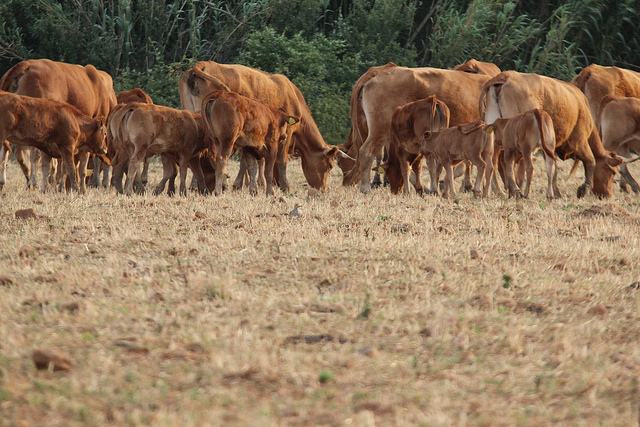How might this scene change with the seasons? In the heart of spring, this scene would burst with vitality as carpets of fresh green grass blanket the field, dotted with colorful wildflowers. The cows would seem livelier, their coats sleek under the invigorating sun. Summer would see the field bathed in warm, golden light with robust, verdant growth. By autumn, the grass would take on a richer, burnt hue, and the cows would graze on the remnants of the summer's bounty, while the trees in the background showcase a palette of oranges, reds, and yellows. Winter might transform the field into a stark, frosty landscape, with the grass browned and earth hardened, leaving the cows huddled together for warmth, their breaths visible in the cold air, creating a scene of serene endurance.  Imagine a day when all the cows decide to go on an adventure. What happens next? One crisp morning, driven by the whisper of wanderlust, the cows decide to break their routine and embark on an unexpected journey. Led by the most adventurous among them, they weave through the boundaries of their familiar field, venturing into the unknown countryside. Their expedition takes them through enchanting forests where dappled sunlight plays upon the ground, across babbling brooks that offer cool, refreshing drinks, and up gentle hills that present a panoramic view of the vast world beyond their meadow. Along the way, they encounter various woodland creatures, forge new paths, and even discover hidden clearings with the most succulent grass they’ve ever tasted. As twilight descends, painting the sky in hues of pink and purple, the cows, filled with new experiences and tales of newfound friends, slowly make their way back. They reunite under the starlit sky, feeling a profound bond not just with the land they roamed, but also with each other, knowing their meadow holds even more mysteries to uncover in their next adventure. 